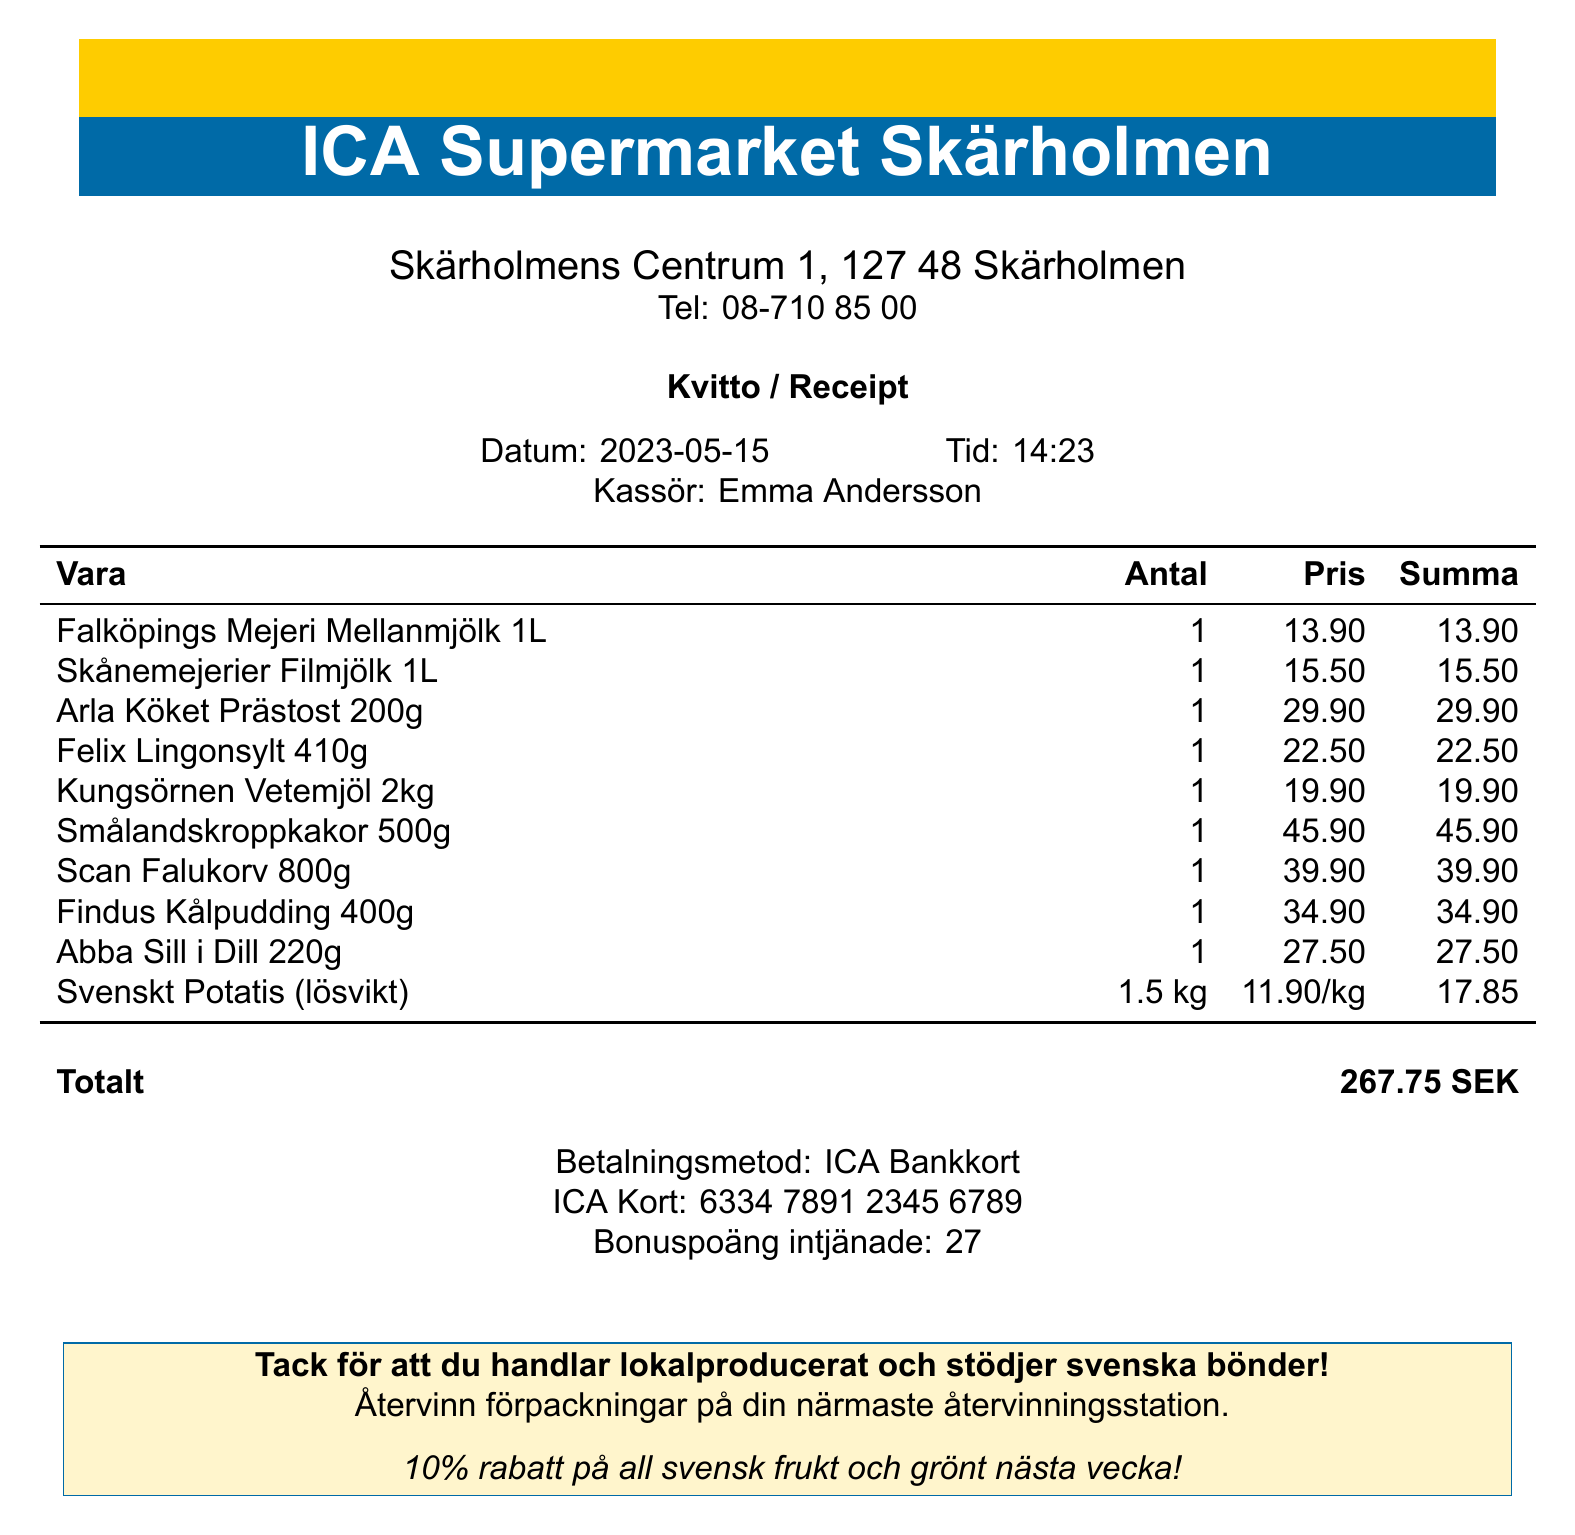What is the store's name? The store's name is displayed prominently at the top of the receipt.
Answer: ICA Supermarket Skärholmen What is the date of the transaction? The date is shown near the top of the receipt, indicating when the purchase was made.
Answer: 2023-05-15 Who was the cashier? The cashier's name is provided on the receipt, indicating who processed the transaction.
Answer: Emma Andersson What is the total amount spent? The total amount is listed at the bottom of the receipt, summarizing the total expense.
Answer: 267.75 SEK How much did the Falköpings Mejeri Mellanmjölk cost? The price of each item is recorded in the itemized list; it specifies the cost for this particular product.
Answer: 13.90 How many loyalty points were earned? The earned loyalty points section specifies the number of points collected from this transaction.
Answer: 27 What is the unit price of Svenskt Potatis? The unit price is disclosed in the itemized list for this product, indicating how much it costs per kilogram.
Answer: 11.90/kg What promotion is mentioned for next week? The receipt includes a promotion for next week, which encourages purchasing certain items.
Answer: 10% rabatt på all svensk frukt och grönt nästa vecka! What message is included about local produce? An eco-friendly message is provided to highlight support for local farming.
Answer: Tack för att du handlar lokalproducerat och stödjer svenska bönder! 